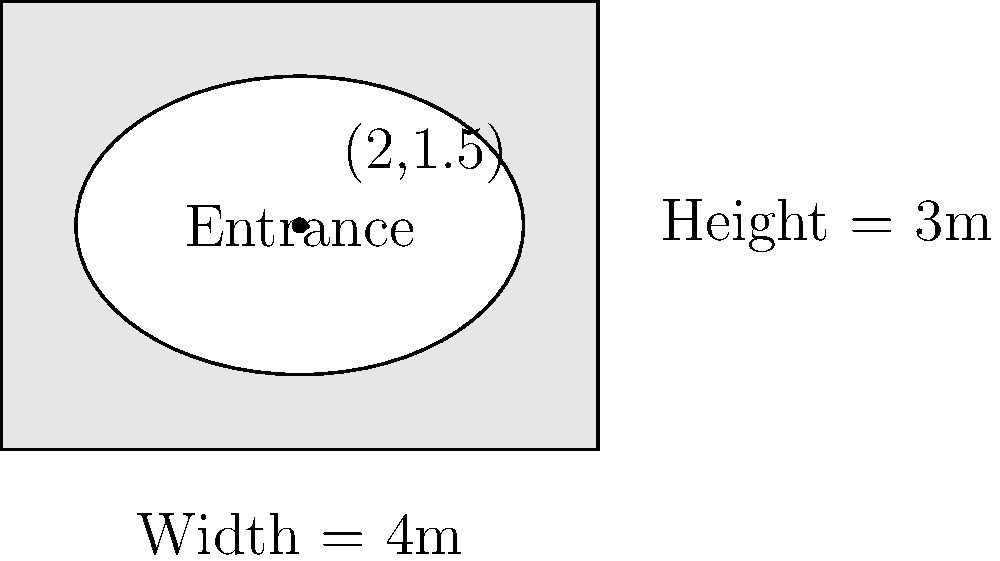A rectangular mineshaft entrance is being designed with a width of 4 meters and a height of 3 meters. The entrance will be elliptical in shape, centered at the point (2,1.5) within the rectangle. What should be the dimensions of the semi-major and semi-minor axes of the ellipse to maximize the area of the entrance while fitting within the rectangular frame? To solve this optimization problem, we'll follow these steps:

1) The equation of an ellipse centered at (h,k) is:
   $$\frac{(x-h)^2}{a^2} + \frac{(y-k)^2}{b^2} = 1$$
   where a and b are the semi-major and semi-minor axes.

2) Given the rectangular frame, we know that:
   - The maximum horizontal distance from the center to the edge is 2m
   - The maximum vertical distance from the center to the edge is 1.5m

3) Therefore, to fit within the frame:
   $$a \leq 2$$ and $$b \leq 1.5$$

4) The area of an ellipse is given by:
   $$A = \pi ab$$

5) To maximize the area, we should use the maximum possible values:
   $$a = 2$$ and $$b = 1.5$$

6) The maximum area is thus:
   $$A = \pi(2)(1.5) = 3\pi$$

Therefore, the optimal dimensions for the elliptical entrance are:
- Semi-major axis (horizontal): 2 meters
- Semi-minor axis (vertical): 1.5 meters
Answer: Semi-major axis: 2m, Semi-minor axis: 1.5m 